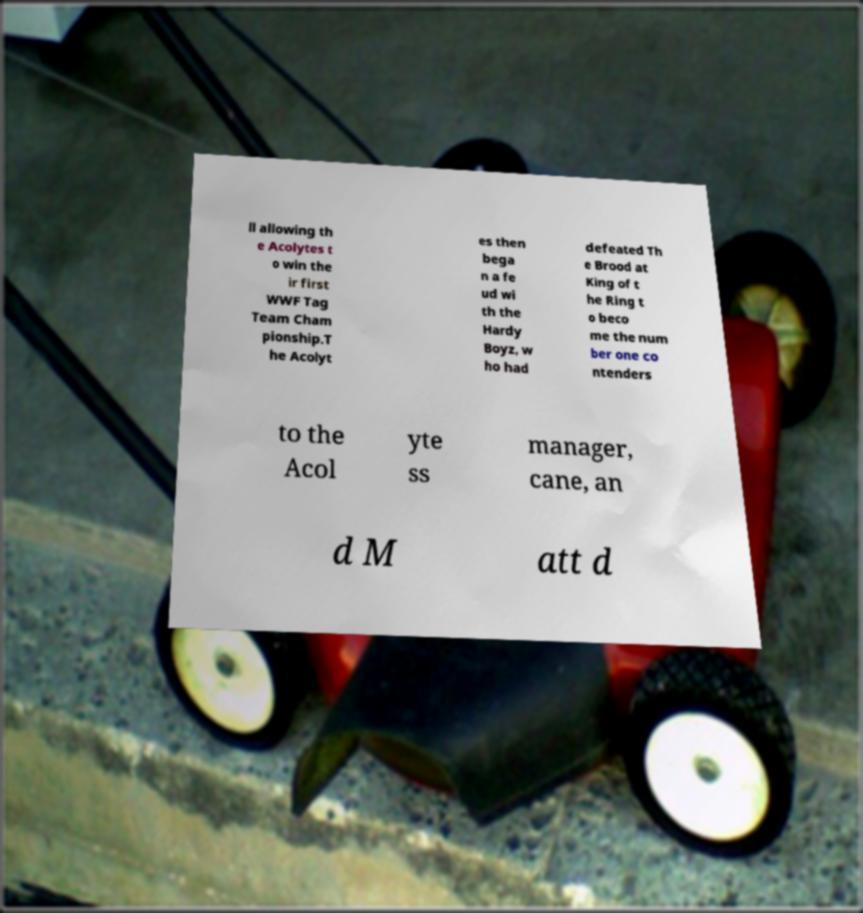Could you assist in decoding the text presented in this image and type it out clearly? ll allowing th e Acolytes t o win the ir first WWF Tag Team Cham pionship.T he Acolyt es then bega n a fe ud wi th the Hardy Boyz, w ho had defeated Th e Brood at King of t he Ring t o beco me the num ber one co ntenders to the Acol yte ss manager, cane, an d M att d 